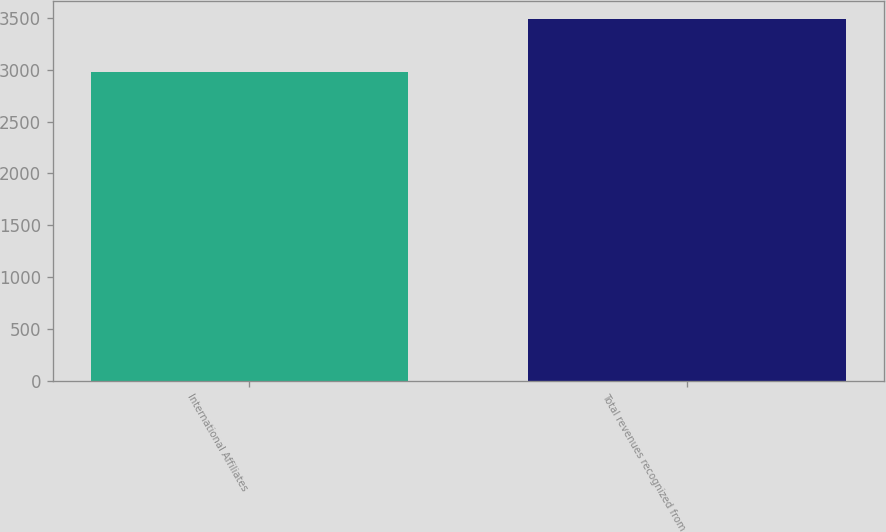<chart> <loc_0><loc_0><loc_500><loc_500><bar_chart><fcel>International Affiliates<fcel>Total revenues recognized from<nl><fcel>2983<fcel>3492<nl></chart> 